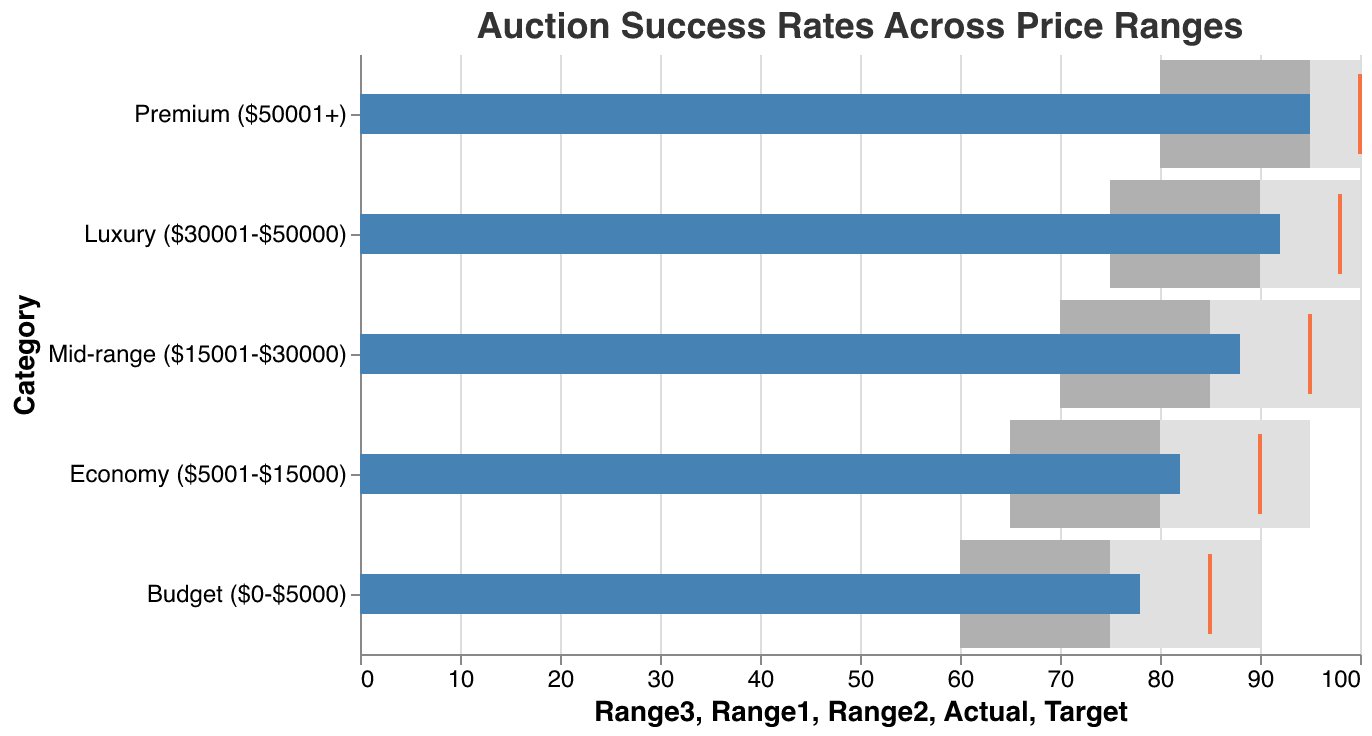What is the title of the figure? The title of a chart is typically displayed at the top. For this figure, the title reads "Auction Success Rates Across Price Ranges."
Answer: Auction Success Rates Across Price Ranges What is the actual success rate for the Mid-range category? To find the actual success rate, locate the Mid-range category on the y-axis and refer to the corresponding blue bar. It shows a success rate of 88.
Answer: 88 Which price range has the highest target success rate? To determine the highest target success rate, inspect the red tick marks for each category and find the highest value. The Premium ($50001+) category has the highest target success rate at 100.
Answer: Premium ($50001+) How close is the actual success rate to the target in the Budget category? Compare the blue bar (actual success rate of 78) and the red tick mark (target of 85). The difference is 85 - 78 = 7.
Answer: 7 Which category has the smallest difference between the actual and target success rates? Compute the difference for each category: Budget (7), Economy (8), Mid-range (7), Luxury (6), Premium (5). The Premium category has the smallest difference at 5.
Answer: Premium ($50001+) Are there any categories where the actual success rate exceeds the Range2 benchmark? The Range2 benchmark values are 75, 80, 85, 90, 95. Actual success rates exceeding Range2 are 82 for Economy, 88 for Mid-range, 92 for Luxury, and 95 for Premium.
Answer: Yes (Economy, Mid-range, Luxury, Premium) Which categories have an actual success rate that falls short of the target? Compare the actual rates (78, 82, 88, 92, 95) with their respective targets (85, 90, 95, 98, 100). All categories fall short: Budget (78 vs 85), Economy (82 vs 90), Mid-range (88 vs 95), Luxury (92 vs 98), Premium (95 vs 100).
Answer: All Categories What is the average target success rate across all categories? Sum the target values (85 + 90 + 95 + 98 + 100) and divide by the number of categories (5). The calculation is (85 + 90 + 95 + 98 + 100) / 5 = 93.6.
Answer: 93.6 